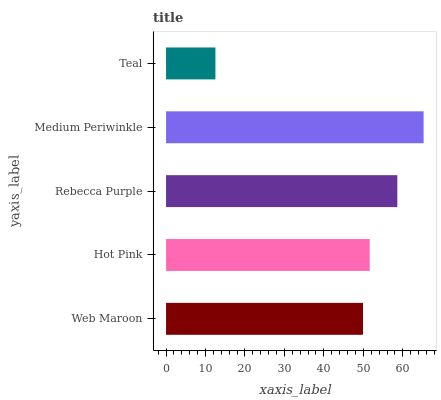Is Teal the minimum?
Answer yes or no. Yes. Is Medium Periwinkle the maximum?
Answer yes or no. Yes. Is Hot Pink the minimum?
Answer yes or no. No. Is Hot Pink the maximum?
Answer yes or no. No. Is Hot Pink greater than Web Maroon?
Answer yes or no. Yes. Is Web Maroon less than Hot Pink?
Answer yes or no. Yes. Is Web Maroon greater than Hot Pink?
Answer yes or no. No. Is Hot Pink less than Web Maroon?
Answer yes or no. No. Is Hot Pink the high median?
Answer yes or no. Yes. Is Hot Pink the low median?
Answer yes or no. Yes. Is Web Maroon the high median?
Answer yes or no. No. Is Rebecca Purple the low median?
Answer yes or no. No. 